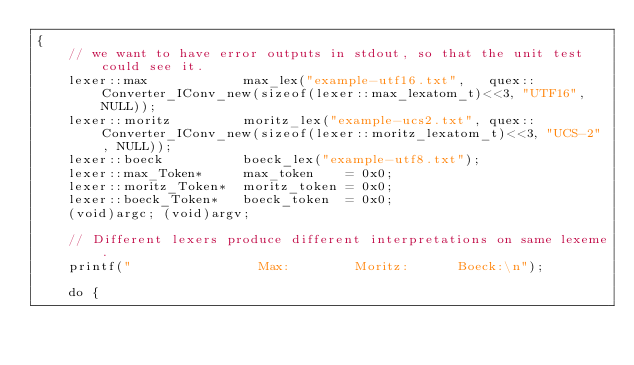<code> <loc_0><loc_0><loc_500><loc_500><_C++_>{        
    // we want to have error outputs in stdout, so that the unit test could see it.
    lexer::max            max_lex("example-utf16.txt",   quex::Converter_IConv_new(sizeof(lexer::max_lexatom_t)<<3, "UTF16", NULL));
    lexer::moritz         moritz_lex("example-ucs2.txt", quex::Converter_IConv_new(sizeof(lexer::moritz_lexatom_t)<<3, "UCS-2", NULL));
    lexer::boeck          boeck_lex("example-utf8.txt");
    lexer::max_Token*     max_token    = 0x0;
    lexer::moritz_Token*  moritz_token = 0x0;
    lexer::boeck_Token*   boeck_token  = 0x0;
    (void)argc; (void)argv;

    // Different lexers produce different interpretations on same lexeme.
    printf("                Max:        Moritz:      Boeck:\n");

    do {</code> 